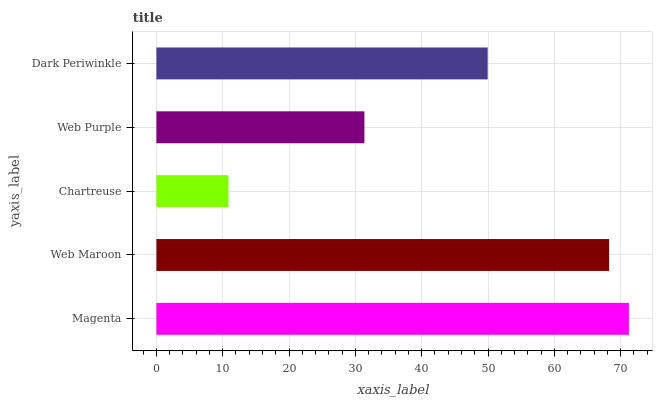Is Chartreuse the minimum?
Answer yes or no. Yes. Is Magenta the maximum?
Answer yes or no. Yes. Is Web Maroon the minimum?
Answer yes or no. No. Is Web Maroon the maximum?
Answer yes or no. No. Is Magenta greater than Web Maroon?
Answer yes or no. Yes. Is Web Maroon less than Magenta?
Answer yes or no. Yes. Is Web Maroon greater than Magenta?
Answer yes or no. No. Is Magenta less than Web Maroon?
Answer yes or no. No. Is Dark Periwinkle the high median?
Answer yes or no. Yes. Is Dark Periwinkle the low median?
Answer yes or no. Yes. Is Web Maroon the high median?
Answer yes or no. No. Is Chartreuse the low median?
Answer yes or no. No. 